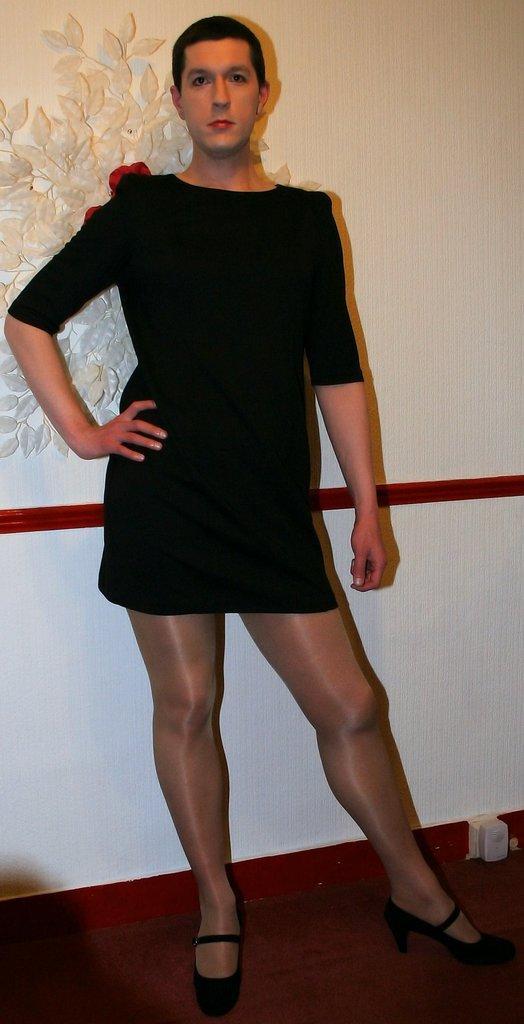Can you describe this image briefly? This image consists of a person wearing a black dress and black shoe. At the bottom, there is a floor. In the background, there is a wall. And we can see an artificial plant on the wall. 